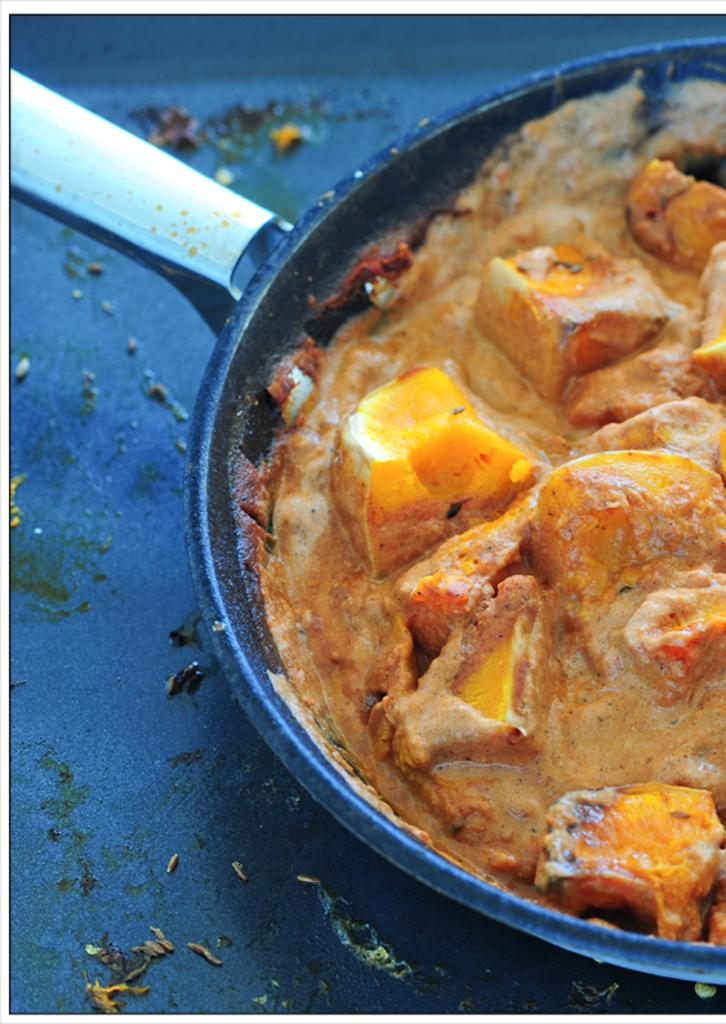What is in the pan that is visible in the image? There is a pan with food items in the image. Where might the pan be located in the image? The pan may be placed on the floor. In which type of setting is the image likely taken? The image is likely taken in a room. How many crackers are visible in the image? There are no crackers present in the image. Is there a sheep visible in the image? No, there is no sheep present in the image. 